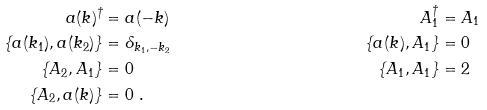Convert formula to latex. <formula><loc_0><loc_0><loc_500><loc_500>a ( k ) ^ { \dagger } & = a ( - k ) & A _ { 1 } ^ { \dagger } & = A _ { 1 } \\ \{ a ( k _ { 1 } ) , a ( k _ { 2 } ) \} & = \delta _ { k _ { 1 } , - k _ { 2 } } & \{ a ( k ) , A _ { 1 } \} & = 0 \\ \{ A _ { 2 } , A _ { 1 } \} & = 0 & \{ A _ { 1 } , A _ { 1 } \} & = 2 \\ \{ A _ { 2 } , a ( k ) \} & = 0 \ .</formula> 